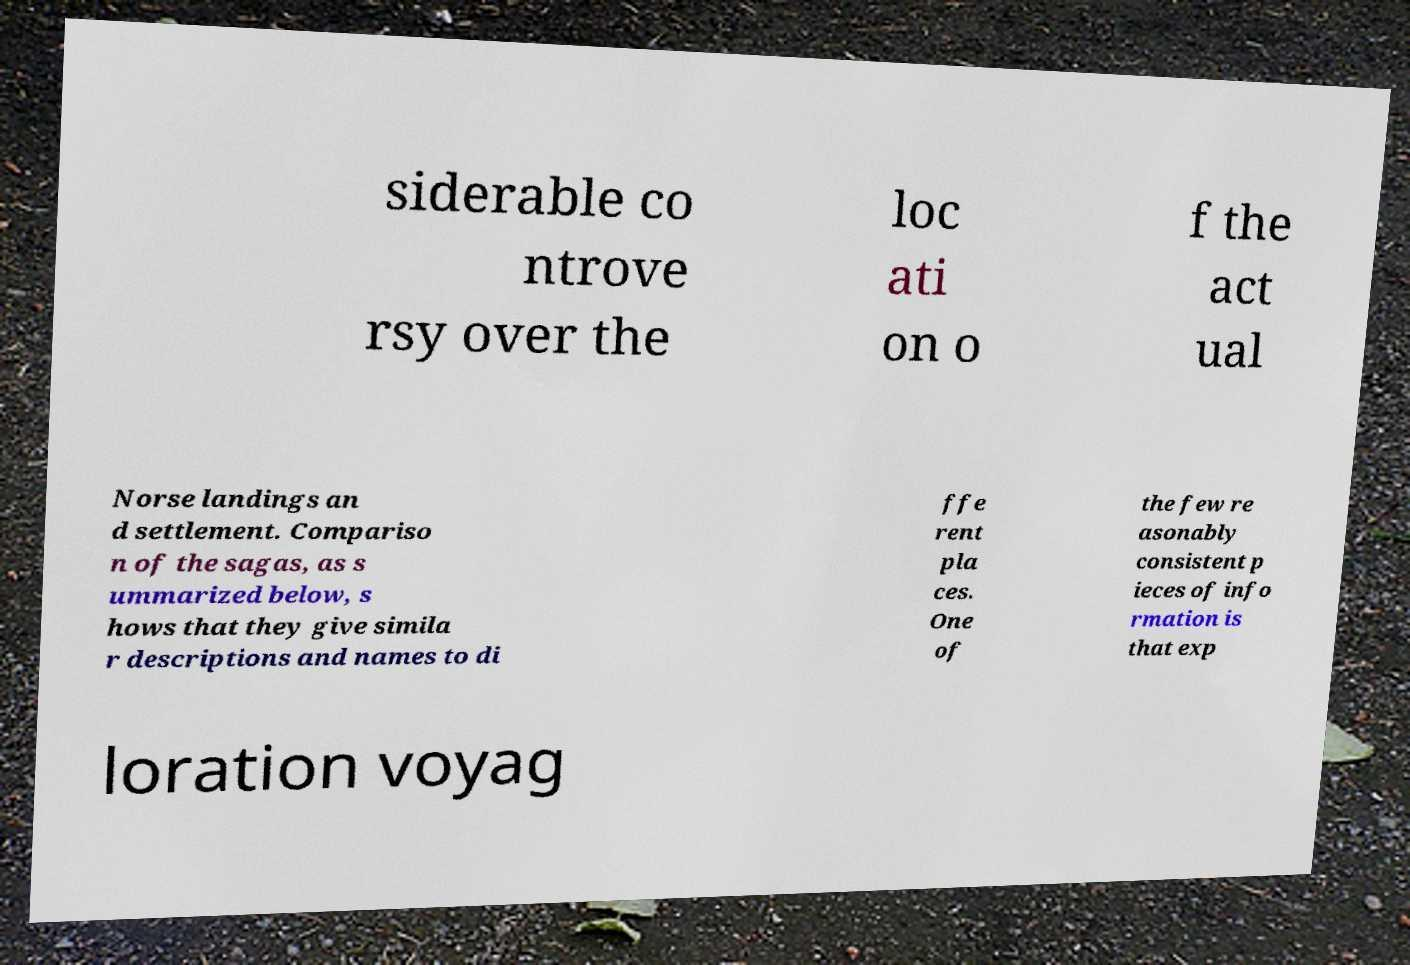What messages or text are displayed in this image? I need them in a readable, typed format. siderable co ntrove rsy over the loc ati on o f the act ual Norse landings an d settlement. Compariso n of the sagas, as s ummarized below, s hows that they give simila r descriptions and names to di ffe rent pla ces. One of the few re asonably consistent p ieces of info rmation is that exp loration voyag 